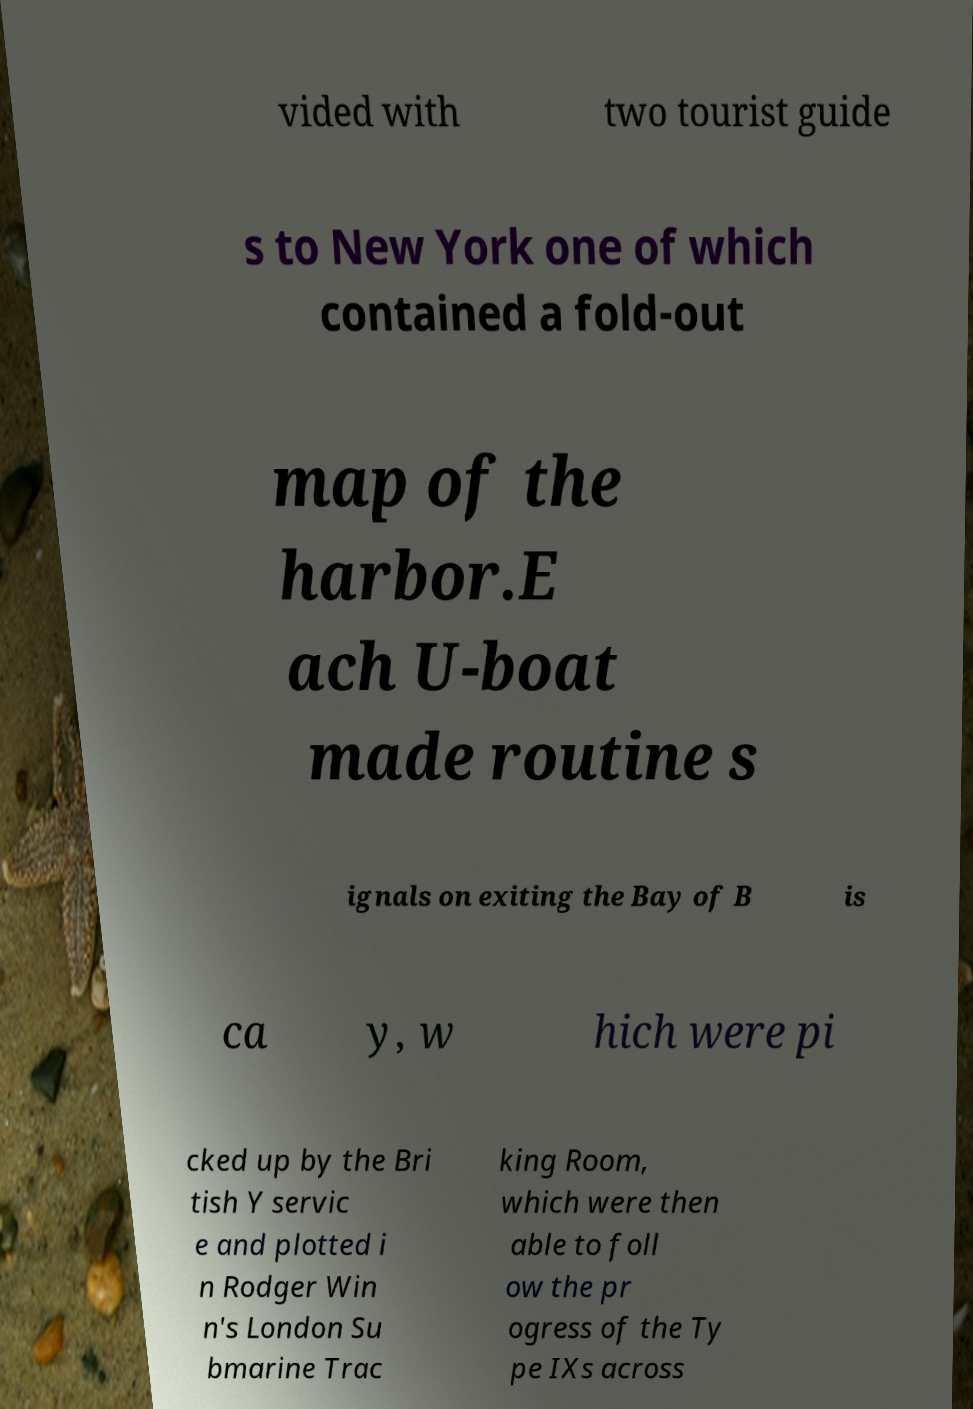Can you read and provide the text displayed in the image?This photo seems to have some interesting text. Can you extract and type it out for me? vided with two tourist guide s to New York one of which contained a fold-out map of the harbor.E ach U-boat made routine s ignals on exiting the Bay of B is ca y, w hich were pi cked up by the Bri tish Y servic e and plotted i n Rodger Win n's London Su bmarine Trac king Room, which were then able to foll ow the pr ogress of the Ty pe IXs across 